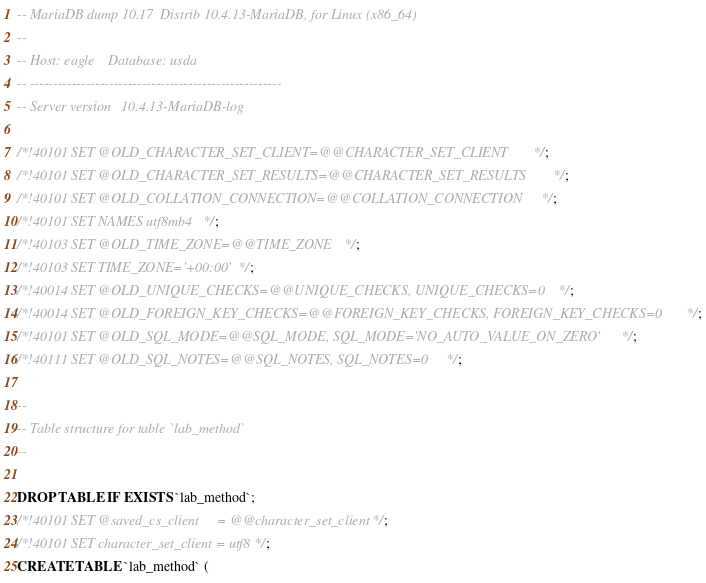Convert code to text. <code><loc_0><loc_0><loc_500><loc_500><_SQL_>-- MariaDB dump 10.17  Distrib 10.4.13-MariaDB, for Linux (x86_64)
--
-- Host: eagle    Database: usda
-- ------------------------------------------------------
-- Server version	10.4.13-MariaDB-log

/*!40101 SET @OLD_CHARACTER_SET_CLIENT=@@CHARACTER_SET_CLIENT */;
/*!40101 SET @OLD_CHARACTER_SET_RESULTS=@@CHARACTER_SET_RESULTS */;
/*!40101 SET @OLD_COLLATION_CONNECTION=@@COLLATION_CONNECTION */;
/*!40101 SET NAMES utf8mb4 */;
/*!40103 SET @OLD_TIME_ZONE=@@TIME_ZONE */;
/*!40103 SET TIME_ZONE='+00:00' */;
/*!40014 SET @OLD_UNIQUE_CHECKS=@@UNIQUE_CHECKS, UNIQUE_CHECKS=0 */;
/*!40014 SET @OLD_FOREIGN_KEY_CHECKS=@@FOREIGN_KEY_CHECKS, FOREIGN_KEY_CHECKS=0 */;
/*!40101 SET @OLD_SQL_MODE=@@SQL_MODE, SQL_MODE='NO_AUTO_VALUE_ON_ZERO' */;
/*!40111 SET @OLD_SQL_NOTES=@@SQL_NOTES, SQL_NOTES=0 */;

--
-- Table structure for table `lab_method`
--

DROP TABLE IF EXISTS `lab_method`;
/*!40101 SET @saved_cs_client     = @@character_set_client */;
/*!40101 SET character_set_client = utf8 */;
CREATE TABLE `lab_method` (</code> 